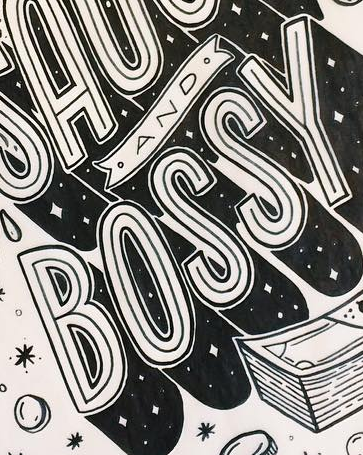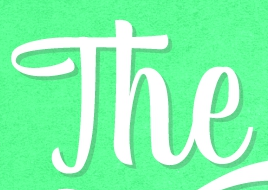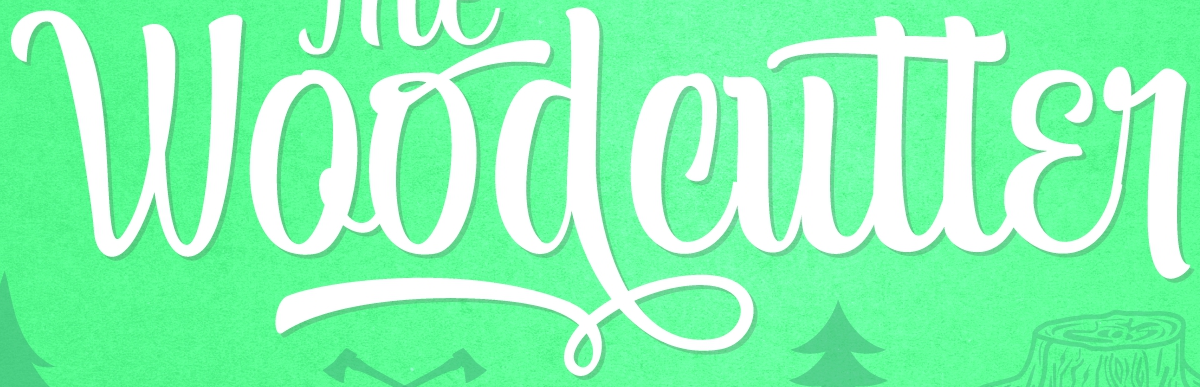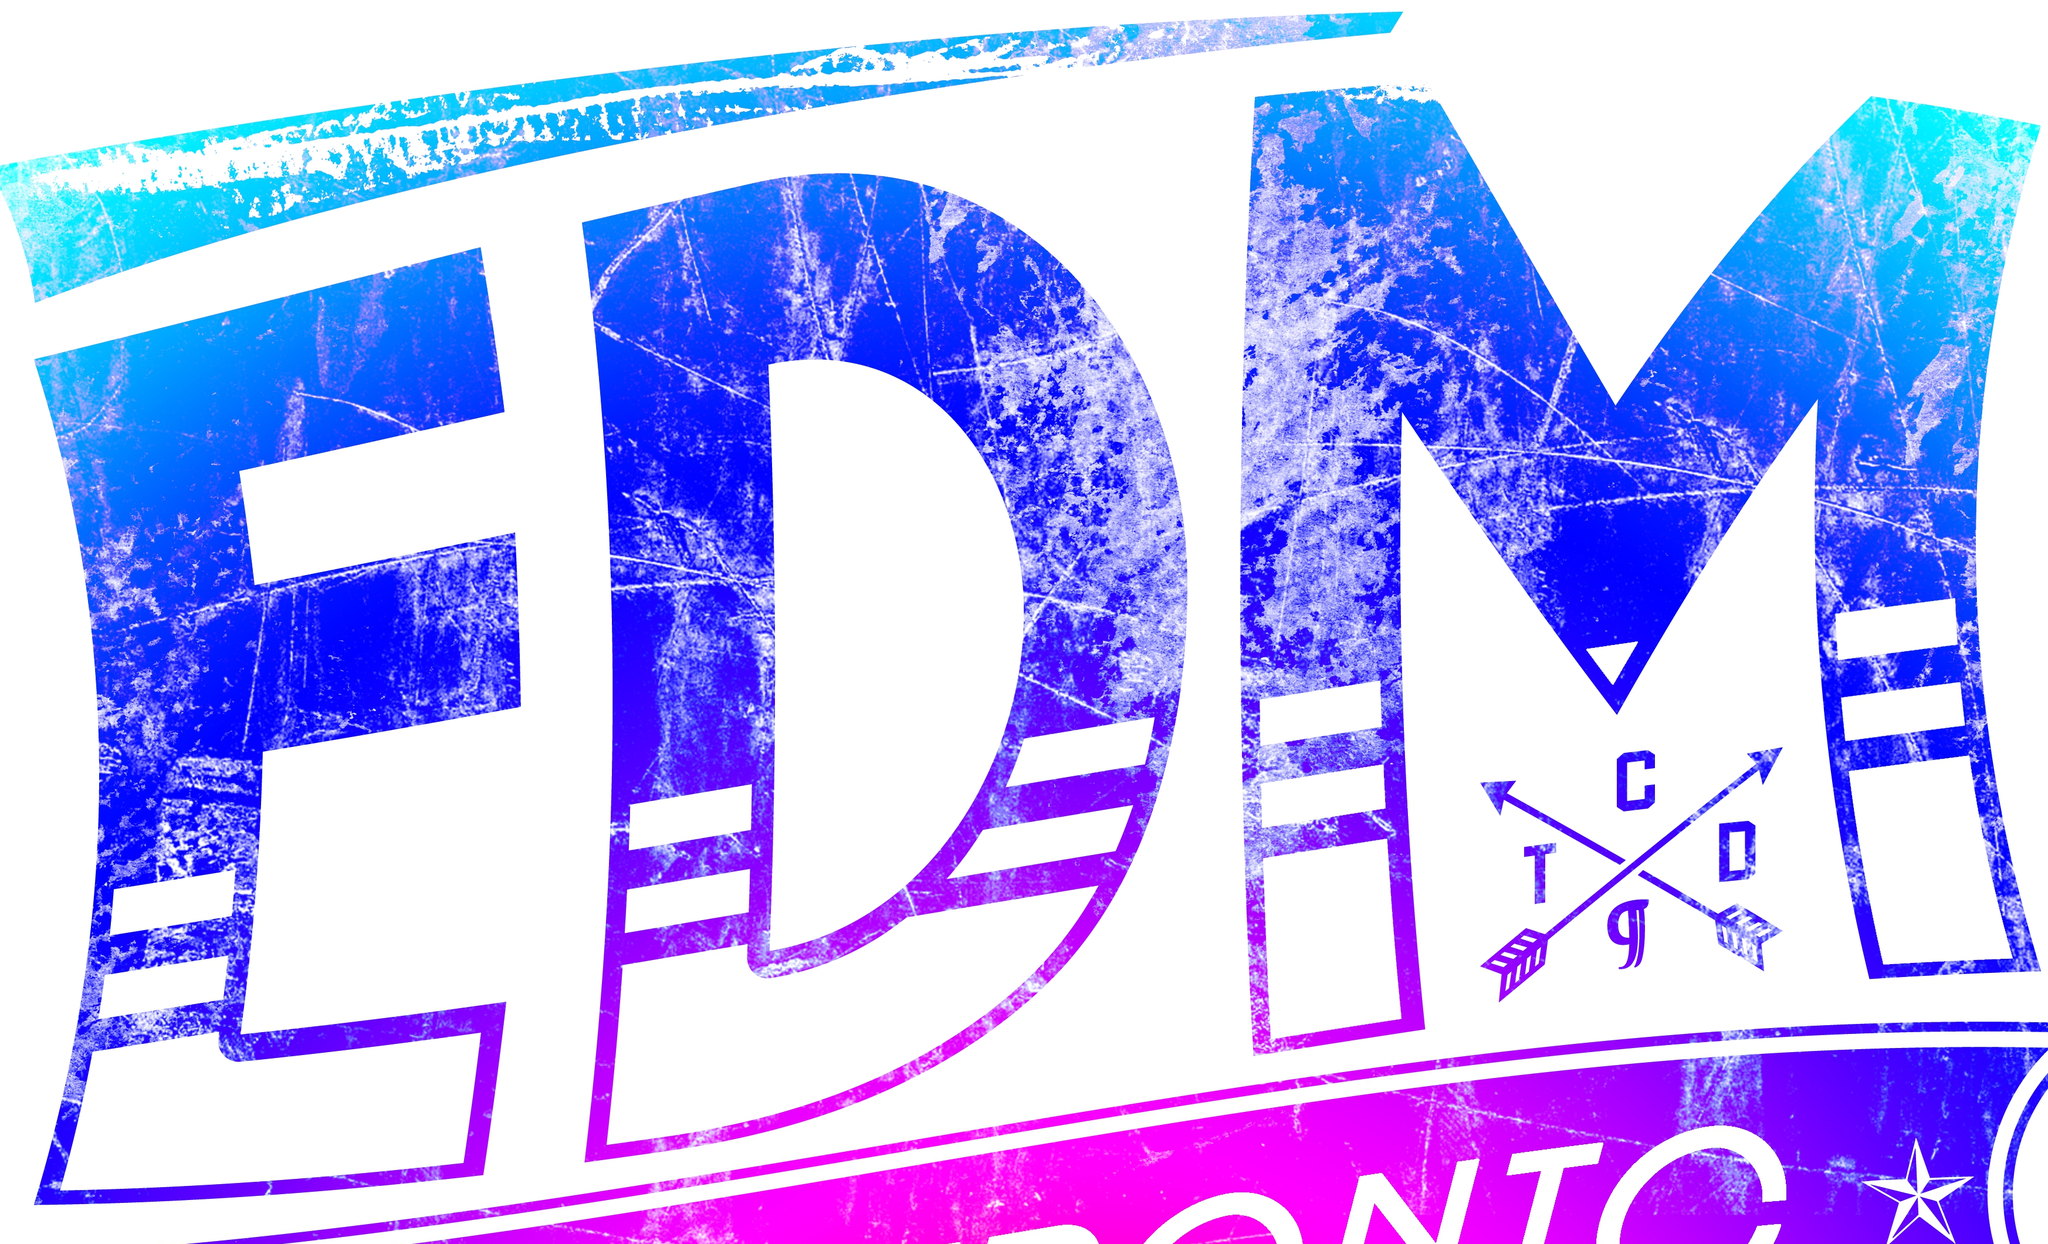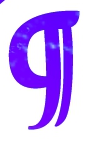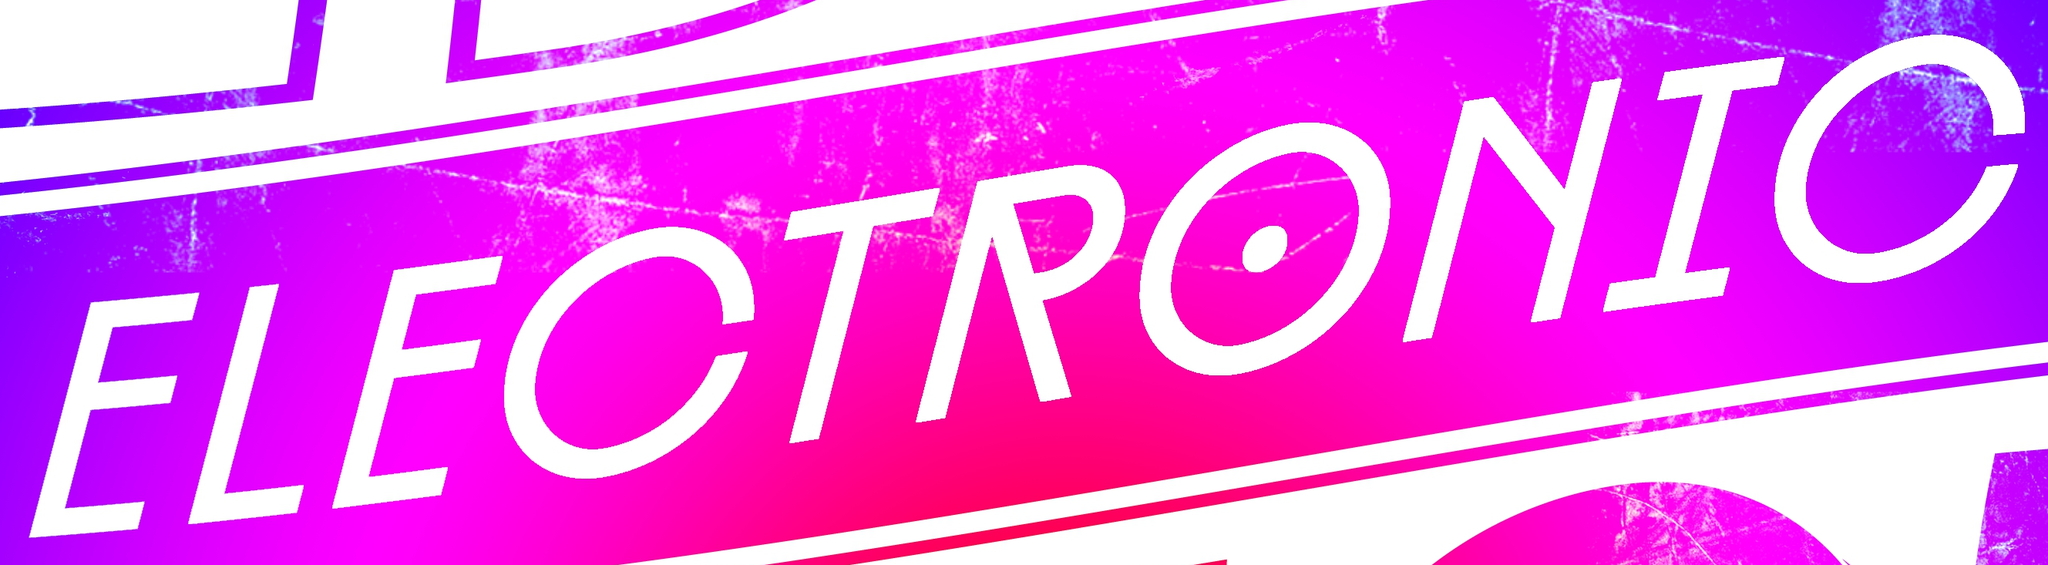What words are shown in these images in order, separated by a semicolon? BOSSY; The; Woodcutter; EDM; g; ELECTRONIC 